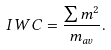Convert formula to latex. <formula><loc_0><loc_0><loc_500><loc_500>I W C = \frac { \sum m ^ { 2 } } { m _ { a v } } .</formula> 